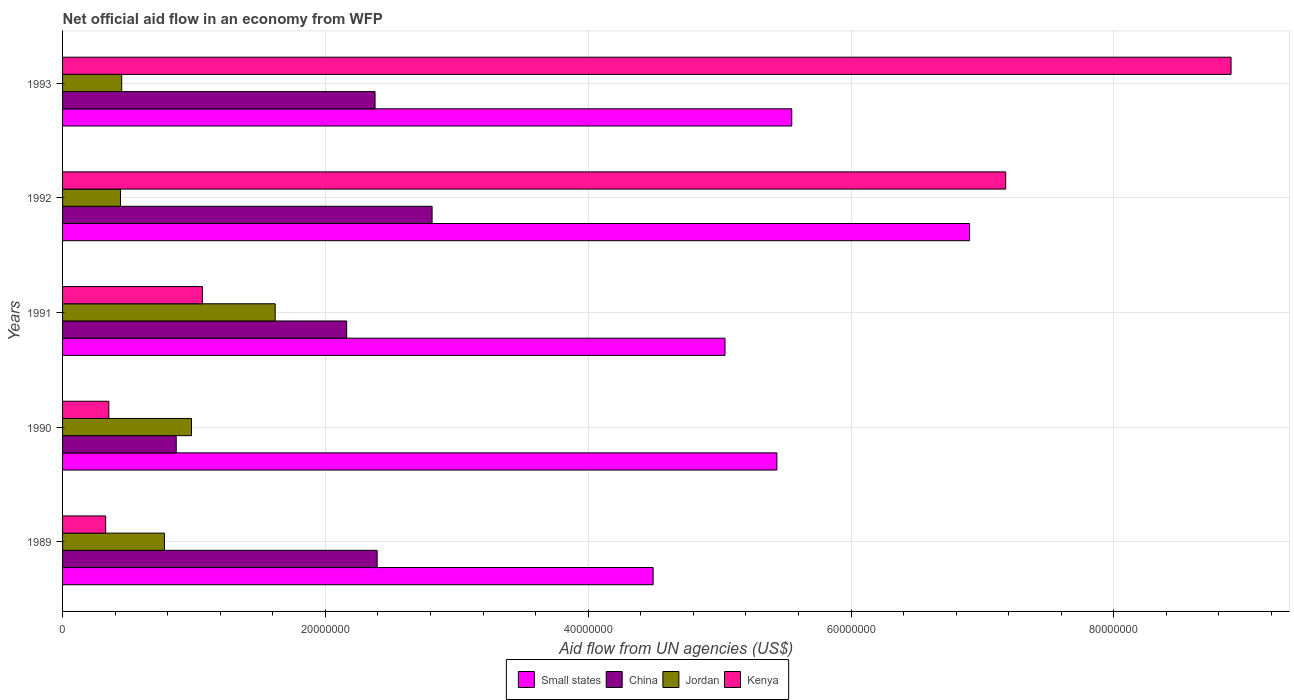How many different coloured bars are there?
Your response must be concise. 4. How many groups of bars are there?
Offer a very short reply. 5. Are the number of bars per tick equal to the number of legend labels?
Your response must be concise. Yes. What is the net official aid flow in Jordan in 1992?
Provide a succinct answer. 4.41e+06. Across all years, what is the maximum net official aid flow in China?
Your answer should be compact. 2.81e+07. Across all years, what is the minimum net official aid flow in China?
Offer a very short reply. 8.65e+06. What is the total net official aid flow in Jordan in the graph?
Your answer should be compact. 4.26e+07. What is the difference between the net official aid flow in Small states in 1991 and that in 1992?
Offer a terse response. -1.86e+07. What is the difference between the net official aid flow in Jordan in 1993 and the net official aid flow in Small states in 1989?
Offer a terse response. -4.04e+07. What is the average net official aid flow in Jordan per year?
Offer a terse response. 8.53e+06. In the year 1991, what is the difference between the net official aid flow in Kenya and net official aid flow in Jordan?
Offer a very short reply. -5.54e+06. In how many years, is the net official aid flow in China greater than 32000000 US$?
Provide a succinct answer. 0. What is the ratio of the net official aid flow in China in 1990 to that in 1993?
Your answer should be very brief. 0.36. Is the difference between the net official aid flow in Kenya in 1990 and 1992 greater than the difference between the net official aid flow in Jordan in 1990 and 1992?
Your answer should be very brief. No. What is the difference between the highest and the second highest net official aid flow in Kenya?
Provide a succinct answer. 1.72e+07. What is the difference between the highest and the lowest net official aid flow in Kenya?
Your response must be concise. 8.56e+07. In how many years, is the net official aid flow in Small states greater than the average net official aid flow in Small states taken over all years?
Give a very brief answer. 2. Is it the case that in every year, the sum of the net official aid flow in Small states and net official aid flow in Kenya is greater than the sum of net official aid flow in China and net official aid flow in Jordan?
Ensure brevity in your answer.  Yes. What does the 2nd bar from the bottom in 1990 represents?
Ensure brevity in your answer.  China. Are all the bars in the graph horizontal?
Make the answer very short. Yes. How many years are there in the graph?
Your answer should be very brief. 5. What is the difference between two consecutive major ticks on the X-axis?
Provide a succinct answer. 2.00e+07. Does the graph contain grids?
Make the answer very short. Yes. How many legend labels are there?
Keep it short and to the point. 4. How are the legend labels stacked?
Provide a succinct answer. Horizontal. What is the title of the graph?
Keep it short and to the point. Net official aid flow in an economy from WFP. What is the label or title of the X-axis?
Your answer should be compact. Aid flow from UN agencies (US$). What is the Aid flow from UN agencies (US$) of Small states in 1989?
Keep it short and to the point. 4.49e+07. What is the Aid flow from UN agencies (US$) in China in 1989?
Keep it short and to the point. 2.39e+07. What is the Aid flow from UN agencies (US$) of Jordan in 1989?
Your answer should be compact. 7.75e+06. What is the Aid flow from UN agencies (US$) of Kenya in 1989?
Your answer should be very brief. 3.28e+06. What is the Aid flow from UN agencies (US$) of Small states in 1990?
Keep it short and to the point. 5.44e+07. What is the Aid flow from UN agencies (US$) of China in 1990?
Make the answer very short. 8.65e+06. What is the Aid flow from UN agencies (US$) in Jordan in 1990?
Offer a very short reply. 9.81e+06. What is the Aid flow from UN agencies (US$) in Kenya in 1990?
Keep it short and to the point. 3.52e+06. What is the Aid flow from UN agencies (US$) in Small states in 1991?
Offer a very short reply. 5.04e+07. What is the Aid flow from UN agencies (US$) of China in 1991?
Make the answer very short. 2.16e+07. What is the Aid flow from UN agencies (US$) of Jordan in 1991?
Ensure brevity in your answer.  1.62e+07. What is the Aid flow from UN agencies (US$) in Kenya in 1991?
Make the answer very short. 1.06e+07. What is the Aid flow from UN agencies (US$) in Small states in 1992?
Your answer should be compact. 6.90e+07. What is the Aid flow from UN agencies (US$) in China in 1992?
Provide a succinct answer. 2.81e+07. What is the Aid flow from UN agencies (US$) in Jordan in 1992?
Ensure brevity in your answer.  4.41e+06. What is the Aid flow from UN agencies (US$) in Kenya in 1992?
Keep it short and to the point. 7.18e+07. What is the Aid flow from UN agencies (US$) of Small states in 1993?
Keep it short and to the point. 5.55e+07. What is the Aid flow from UN agencies (US$) in China in 1993?
Your response must be concise. 2.38e+07. What is the Aid flow from UN agencies (US$) of Jordan in 1993?
Your answer should be very brief. 4.50e+06. What is the Aid flow from UN agencies (US$) in Kenya in 1993?
Ensure brevity in your answer.  8.89e+07. Across all years, what is the maximum Aid flow from UN agencies (US$) of Small states?
Provide a short and direct response. 6.90e+07. Across all years, what is the maximum Aid flow from UN agencies (US$) of China?
Keep it short and to the point. 2.81e+07. Across all years, what is the maximum Aid flow from UN agencies (US$) of Jordan?
Make the answer very short. 1.62e+07. Across all years, what is the maximum Aid flow from UN agencies (US$) in Kenya?
Ensure brevity in your answer.  8.89e+07. Across all years, what is the minimum Aid flow from UN agencies (US$) in Small states?
Offer a terse response. 4.49e+07. Across all years, what is the minimum Aid flow from UN agencies (US$) of China?
Your answer should be very brief. 8.65e+06. Across all years, what is the minimum Aid flow from UN agencies (US$) in Jordan?
Offer a very short reply. 4.41e+06. Across all years, what is the minimum Aid flow from UN agencies (US$) of Kenya?
Offer a very short reply. 3.28e+06. What is the total Aid flow from UN agencies (US$) in Small states in the graph?
Keep it short and to the point. 2.74e+08. What is the total Aid flow from UN agencies (US$) in China in the graph?
Give a very brief answer. 1.06e+08. What is the total Aid flow from UN agencies (US$) in Jordan in the graph?
Ensure brevity in your answer.  4.26e+07. What is the total Aid flow from UN agencies (US$) of Kenya in the graph?
Offer a terse response. 1.78e+08. What is the difference between the Aid flow from UN agencies (US$) in Small states in 1989 and that in 1990?
Give a very brief answer. -9.42e+06. What is the difference between the Aid flow from UN agencies (US$) of China in 1989 and that in 1990?
Provide a short and direct response. 1.53e+07. What is the difference between the Aid flow from UN agencies (US$) in Jordan in 1989 and that in 1990?
Ensure brevity in your answer.  -2.06e+06. What is the difference between the Aid flow from UN agencies (US$) of Kenya in 1989 and that in 1990?
Provide a short and direct response. -2.40e+05. What is the difference between the Aid flow from UN agencies (US$) of Small states in 1989 and that in 1991?
Your answer should be compact. -5.47e+06. What is the difference between the Aid flow from UN agencies (US$) of China in 1989 and that in 1991?
Keep it short and to the point. 2.32e+06. What is the difference between the Aid flow from UN agencies (US$) in Jordan in 1989 and that in 1991?
Provide a succinct answer. -8.43e+06. What is the difference between the Aid flow from UN agencies (US$) of Kenya in 1989 and that in 1991?
Your answer should be very brief. -7.36e+06. What is the difference between the Aid flow from UN agencies (US$) of Small states in 1989 and that in 1992?
Offer a terse response. -2.41e+07. What is the difference between the Aid flow from UN agencies (US$) in China in 1989 and that in 1992?
Make the answer very short. -4.18e+06. What is the difference between the Aid flow from UN agencies (US$) in Jordan in 1989 and that in 1992?
Your response must be concise. 3.34e+06. What is the difference between the Aid flow from UN agencies (US$) in Kenya in 1989 and that in 1992?
Your answer should be very brief. -6.85e+07. What is the difference between the Aid flow from UN agencies (US$) in Small states in 1989 and that in 1993?
Keep it short and to the point. -1.06e+07. What is the difference between the Aid flow from UN agencies (US$) in Jordan in 1989 and that in 1993?
Keep it short and to the point. 3.25e+06. What is the difference between the Aid flow from UN agencies (US$) in Kenya in 1989 and that in 1993?
Give a very brief answer. -8.56e+07. What is the difference between the Aid flow from UN agencies (US$) of Small states in 1990 and that in 1991?
Your response must be concise. 3.95e+06. What is the difference between the Aid flow from UN agencies (US$) of China in 1990 and that in 1991?
Provide a succinct answer. -1.30e+07. What is the difference between the Aid flow from UN agencies (US$) in Jordan in 1990 and that in 1991?
Your answer should be very brief. -6.37e+06. What is the difference between the Aid flow from UN agencies (US$) in Kenya in 1990 and that in 1991?
Ensure brevity in your answer.  -7.12e+06. What is the difference between the Aid flow from UN agencies (US$) in Small states in 1990 and that in 1992?
Provide a short and direct response. -1.47e+07. What is the difference between the Aid flow from UN agencies (US$) in China in 1990 and that in 1992?
Offer a terse response. -1.95e+07. What is the difference between the Aid flow from UN agencies (US$) of Jordan in 1990 and that in 1992?
Keep it short and to the point. 5.40e+06. What is the difference between the Aid flow from UN agencies (US$) of Kenya in 1990 and that in 1992?
Provide a short and direct response. -6.82e+07. What is the difference between the Aid flow from UN agencies (US$) in Small states in 1990 and that in 1993?
Provide a short and direct response. -1.13e+06. What is the difference between the Aid flow from UN agencies (US$) in China in 1990 and that in 1993?
Give a very brief answer. -1.51e+07. What is the difference between the Aid flow from UN agencies (US$) of Jordan in 1990 and that in 1993?
Offer a very short reply. 5.31e+06. What is the difference between the Aid flow from UN agencies (US$) in Kenya in 1990 and that in 1993?
Provide a short and direct response. -8.54e+07. What is the difference between the Aid flow from UN agencies (US$) of Small states in 1991 and that in 1992?
Make the answer very short. -1.86e+07. What is the difference between the Aid flow from UN agencies (US$) of China in 1991 and that in 1992?
Provide a succinct answer. -6.50e+06. What is the difference between the Aid flow from UN agencies (US$) in Jordan in 1991 and that in 1992?
Offer a terse response. 1.18e+07. What is the difference between the Aid flow from UN agencies (US$) of Kenya in 1991 and that in 1992?
Your response must be concise. -6.11e+07. What is the difference between the Aid flow from UN agencies (US$) in Small states in 1991 and that in 1993?
Offer a very short reply. -5.08e+06. What is the difference between the Aid flow from UN agencies (US$) in China in 1991 and that in 1993?
Your answer should be compact. -2.16e+06. What is the difference between the Aid flow from UN agencies (US$) in Jordan in 1991 and that in 1993?
Your answer should be very brief. 1.17e+07. What is the difference between the Aid flow from UN agencies (US$) of Kenya in 1991 and that in 1993?
Provide a short and direct response. -7.83e+07. What is the difference between the Aid flow from UN agencies (US$) in Small states in 1992 and that in 1993?
Your answer should be very brief. 1.35e+07. What is the difference between the Aid flow from UN agencies (US$) in China in 1992 and that in 1993?
Provide a short and direct response. 4.34e+06. What is the difference between the Aid flow from UN agencies (US$) in Kenya in 1992 and that in 1993?
Provide a short and direct response. -1.72e+07. What is the difference between the Aid flow from UN agencies (US$) of Small states in 1989 and the Aid flow from UN agencies (US$) of China in 1990?
Your answer should be very brief. 3.63e+07. What is the difference between the Aid flow from UN agencies (US$) in Small states in 1989 and the Aid flow from UN agencies (US$) in Jordan in 1990?
Provide a succinct answer. 3.51e+07. What is the difference between the Aid flow from UN agencies (US$) of Small states in 1989 and the Aid flow from UN agencies (US$) of Kenya in 1990?
Make the answer very short. 4.14e+07. What is the difference between the Aid flow from UN agencies (US$) in China in 1989 and the Aid flow from UN agencies (US$) in Jordan in 1990?
Provide a succinct answer. 1.41e+07. What is the difference between the Aid flow from UN agencies (US$) in China in 1989 and the Aid flow from UN agencies (US$) in Kenya in 1990?
Offer a very short reply. 2.04e+07. What is the difference between the Aid flow from UN agencies (US$) in Jordan in 1989 and the Aid flow from UN agencies (US$) in Kenya in 1990?
Make the answer very short. 4.23e+06. What is the difference between the Aid flow from UN agencies (US$) in Small states in 1989 and the Aid flow from UN agencies (US$) in China in 1991?
Offer a very short reply. 2.33e+07. What is the difference between the Aid flow from UN agencies (US$) in Small states in 1989 and the Aid flow from UN agencies (US$) in Jordan in 1991?
Keep it short and to the point. 2.88e+07. What is the difference between the Aid flow from UN agencies (US$) of Small states in 1989 and the Aid flow from UN agencies (US$) of Kenya in 1991?
Provide a short and direct response. 3.43e+07. What is the difference between the Aid flow from UN agencies (US$) in China in 1989 and the Aid flow from UN agencies (US$) in Jordan in 1991?
Offer a very short reply. 7.76e+06. What is the difference between the Aid flow from UN agencies (US$) in China in 1989 and the Aid flow from UN agencies (US$) in Kenya in 1991?
Your answer should be very brief. 1.33e+07. What is the difference between the Aid flow from UN agencies (US$) of Jordan in 1989 and the Aid flow from UN agencies (US$) of Kenya in 1991?
Give a very brief answer. -2.89e+06. What is the difference between the Aid flow from UN agencies (US$) of Small states in 1989 and the Aid flow from UN agencies (US$) of China in 1992?
Your answer should be very brief. 1.68e+07. What is the difference between the Aid flow from UN agencies (US$) of Small states in 1989 and the Aid flow from UN agencies (US$) of Jordan in 1992?
Your answer should be compact. 4.05e+07. What is the difference between the Aid flow from UN agencies (US$) of Small states in 1989 and the Aid flow from UN agencies (US$) of Kenya in 1992?
Offer a very short reply. -2.68e+07. What is the difference between the Aid flow from UN agencies (US$) in China in 1989 and the Aid flow from UN agencies (US$) in Jordan in 1992?
Your response must be concise. 1.95e+07. What is the difference between the Aid flow from UN agencies (US$) of China in 1989 and the Aid flow from UN agencies (US$) of Kenya in 1992?
Keep it short and to the point. -4.78e+07. What is the difference between the Aid flow from UN agencies (US$) in Jordan in 1989 and the Aid flow from UN agencies (US$) in Kenya in 1992?
Offer a terse response. -6.40e+07. What is the difference between the Aid flow from UN agencies (US$) of Small states in 1989 and the Aid flow from UN agencies (US$) of China in 1993?
Your answer should be very brief. 2.12e+07. What is the difference between the Aid flow from UN agencies (US$) in Small states in 1989 and the Aid flow from UN agencies (US$) in Jordan in 1993?
Give a very brief answer. 4.04e+07. What is the difference between the Aid flow from UN agencies (US$) in Small states in 1989 and the Aid flow from UN agencies (US$) in Kenya in 1993?
Offer a terse response. -4.40e+07. What is the difference between the Aid flow from UN agencies (US$) in China in 1989 and the Aid flow from UN agencies (US$) in Jordan in 1993?
Your answer should be very brief. 1.94e+07. What is the difference between the Aid flow from UN agencies (US$) of China in 1989 and the Aid flow from UN agencies (US$) of Kenya in 1993?
Your answer should be very brief. -6.50e+07. What is the difference between the Aid flow from UN agencies (US$) in Jordan in 1989 and the Aid flow from UN agencies (US$) in Kenya in 1993?
Your answer should be very brief. -8.12e+07. What is the difference between the Aid flow from UN agencies (US$) in Small states in 1990 and the Aid flow from UN agencies (US$) in China in 1991?
Your answer should be very brief. 3.27e+07. What is the difference between the Aid flow from UN agencies (US$) of Small states in 1990 and the Aid flow from UN agencies (US$) of Jordan in 1991?
Your answer should be compact. 3.82e+07. What is the difference between the Aid flow from UN agencies (US$) in Small states in 1990 and the Aid flow from UN agencies (US$) in Kenya in 1991?
Your answer should be very brief. 4.37e+07. What is the difference between the Aid flow from UN agencies (US$) in China in 1990 and the Aid flow from UN agencies (US$) in Jordan in 1991?
Provide a succinct answer. -7.53e+06. What is the difference between the Aid flow from UN agencies (US$) in China in 1990 and the Aid flow from UN agencies (US$) in Kenya in 1991?
Offer a terse response. -1.99e+06. What is the difference between the Aid flow from UN agencies (US$) of Jordan in 1990 and the Aid flow from UN agencies (US$) of Kenya in 1991?
Keep it short and to the point. -8.30e+05. What is the difference between the Aid flow from UN agencies (US$) of Small states in 1990 and the Aid flow from UN agencies (US$) of China in 1992?
Offer a very short reply. 2.62e+07. What is the difference between the Aid flow from UN agencies (US$) of Small states in 1990 and the Aid flow from UN agencies (US$) of Jordan in 1992?
Make the answer very short. 5.00e+07. What is the difference between the Aid flow from UN agencies (US$) of Small states in 1990 and the Aid flow from UN agencies (US$) of Kenya in 1992?
Make the answer very short. -1.74e+07. What is the difference between the Aid flow from UN agencies (US$) in China in 1990 and the Aid flow from UN agencies (US$) in Jordan in 1992?
Offer a terse response. 4.24e+06. What is the difference between the Aid flow from UN agencies (US$) in China in 1990 and the Aid flow from UN agencies (US$) in Kenya in 1992?
Your answer should be compact. -6.31e+07. What is the difference between the Aid flow from UN agencies (US$) of Jordan in 1990 and the Aid flow from UN agencies (US$) of Kenya in 1992?
Your response must be concise. -6.20e+07. What is the difference between the Aid flow from UN agencies (US$) in Small states in 1990 and the Aid flow from UN agencies (US$) in China in 1993?
Give a very brief answer. 3.06e+07. What is the difference between the Aid flow from UN agencies (US$) in Small states in 1990 and the Aid flow from UN agencies (US$) in Jordan in 1993?
Your answer should be very brief. 4.99e+07. What is the difference between the Aid flow from UN agencies (US$) in Small states in 1990 and the Aid flow from UN agencies (US$) in Kenya in 1993?
Your answer should be very brief. -3.46e+07. What is the difference between the Aid flow from UN agencies (US$) in China in 1990 and the Aid flow from UN agencies (US$) in Jordan in 1993?
Give a very brief answer. 4.15e+06. What is the difference between the Aid flow from UN agencies (US$) of China in 1990 and the Aid flow from UN agencies (US$) of Kenya in 1993?
Ensure brevity in your answer.  -8.03e+07. What is the difference between the Aid flow from UN agencies (US$) of Jordan in 1990 and the Aid flow from UN agencies (US$) of Kenya in 1993?
Provide a succinct answer. -7.91e+07. What is the difference between the Aid flow from UN agencies (US$) of Small states in 1991 and the Aid flow from UN agencies (US$) of China in 1992?
Offer a terse response. 2.23e+07. What is the difference between the Aid flow from UN agencies (US$) in Small states in 1991 and the Aid flow from UN agencies (US$) in Jordan in 1992?
Give a very brief answer. 4.60e+07. What is the difference between the Aid flow from UN agencies (US$) of Small states in 1991 and the Aid flow from UN agencies (US$) of Kenya in 1992?
Ensure brevity in your answer.  -2.14e+07. What is the difference between the Aid flow from UN agencies (US$) in China in 1991 and the Aid flow from UN agencies (US$) in Jordan in 1992?
Ensure brevity in your answer.  1.72e+07. What is the difference between the Aid flow from UN agencies (US$) in China in 1991 and the Aid flow from UN agencies (US$) in Kenya in 1992?
Give a very brief answer. -5.02e+07. What is the difference between the Aid flow from UN agencies (US$) in Jordan in 1991 and the Aid flow from UN agencies (US$) in Kenya in 1992?
Keep it short and to the point. -5.56e+07. What is the difference between the Aid flow from UN agencies (US$) of Small states in 1991 and the Aid flow from UN agencies (US$) of China in 1993?
Your answer should be compact. 2.66e+07. What is the difference between the Aid flow from UN agencies (US$) of Small states in 1991 and the Aid flow from UN agencies (US$) of Jordan in 1993?
Ensure brevity in your answer.  4.59e+07. What is the difference between the Aid flow from UN agencies (US$) of Small states in 1991 and the Aid flow from UN agencies (US$) of Kenya in 1993?
Provide a succinct answer. -3.85e+07. What is the difference between the Aid flow from UN agencies (US$) in China in 1991 and the Aid flow from UN agencies (US$) in Jordan in 1993?
Your answer should be compact. 1.71e+07. What is the difference between the Aid flow from UN agencies (US$) of China in 1991 and the Aid flow from UN agencies (US$) of Kenya in 1993?
Provide a succinct answer. -6.73e+07. What is the difference between the Aid flow from UN agencies (US$) of Jordan in 1991 and the Aid flow from UN agencies (US$) of Kenya in 1993?
Offer a terse response. -7.27e+07. What is the difference between the Aid flow from UN agencies (US$) of Small states in 1992 and the Aid flow from UN agencies (US$) of China in 1993?
Offer a very short reply. 4.52e+07. What is the difference between the Aid flow from UN agencies (US$) of Small states in 1992 and the Aid flow from UN agencies (US$) of Jordan in 1993?
Your answer should be compact. 6.45e+07. What is the difference between the Aid flow from UN agencies (US$) in Small states in 1992 and the Aid flow from UN agencies (US$) in Kenya in 1993?
Your response must be concise. -1.99e+07. What is the difference between the Aid flow from UN agencies (US$) in China in 1992 and the Aid flow from UN agencies (US$) in Jordan in 1993?
Provide a succinct answer. 2.36e+07. What is the difference between the Aid flow from UN agencies (US$) in China in 1992 and the Aid flow from UN agencies (US$) in Kenya in 1993?
Offer a terse response. -6.08e+07. What is the difference between the Aid flow from UN agencies (US$) of Jordan in 1992 and the Aid flow from UN agencies (US$) of Kenya in 1993?
Offer a terse response. -8.45e+07. What is the average Aid flow from UN agencies (US$) of Small states per year?
Your answer should be very brief. 5.48e+07. What is the average Aid flow from UN agencies (US$) of China per year?
Offer a very short reply. 2.12e+07. What is the average Aid flow from UN agencies (US$) of Jordan per year?
Offer a terse response. 8.53e+06. What is the average Aid flow from UN agencies (US$) of Kenya per year?
Provide a succinct answer. 3.56e+07. In the year 1989, what is the difference between the Aid flow from UN agencies (US$) in Small states and Aid flow from UN agencies (US$) in China?
Ensure brevity in your answer.  2.10e+07. In the year 1989, what is the difference between the Aid flow from UN agencies (US$) in Small states and Aid flow from UN agencies (US$) in Jordan?
Offer a terse response. 3.72e+07. In the year 1989, what is the difference between the Aid flow from UN agencies (US$) in Small states and Aid flow from UN agencies (US$) in Kenya?
Make the answer very short. 4.17e+07. In the year 1989, what is the difference between the Aid flow from UN agencies (US$) of China and Aid flow from UN agencies (US$) of Jordan?
Give a very brief answer. 1.62e+07. In the year 1989, what is the difference between the Aid flow from UN agencies (US$) of China and Aid flow from UN agencies (US$) of Kenya?
Ensure brevity in your answer.  2.07e+07. In the year 1989, what is the difference between the Aid flow from UN agencies (US$) in Jordan and Aid flow from UN agencies (US$) in Kenya?
Ensure brevity in your answer.  4.47e+06. In the year 1990, what is the difference between the Aid flow from UN agencies (US$) in Small states and Aid flow from UN agencies (US$) in China?
Offer a very short reply. 4.57e+07. In the year 1990, what is the difference between the Aid flow from UN agencies (US$) of Small states and Aid flow from UN agencies (US$) of Jordan?
Offer a very short reply. 4.46e+07. In the year 1990, what is the difference between the Aid flow from UN agencies (US$) in Small states and Aid flow from UN agencies (US$) in Kenya?
Your response must be concise. 5.08e+07. In the year 1990, what is the difference between the Aid flow from UN agencies (US$) in China and Aid flow from UN agencies (US$) in Jordan?
Make the answer very short. -1.16e+06. In the year 1990, what is the difference between the Aid flow from UN agencies (US$) in China and Aid flow from UN agencies (US$) in Kenya?
Your answer should be compact. 5.13e+06. In the year 1990, what is the difference between the Aid flow from UN agencies (US$) in Jordan and Aid flow from UN agencies (US$) in Kenya?
Your response must be concise. 6.29e+06. In the year 1991, what is the difference between the Aid flow from UN agencies (US$) of Small states and Aid flow from UN agencies (US$) of China?
Give a very brief answer. 2.88e+07. In the year 1991, what is the difference between the Aid flow from UN agencies (US$) of Small states and Aid flow from UN agencies (US$) of Jordan?
Provide a succinct answer. 3.42e+07. In the year 1991, what is the difference between the Aid flow from UN agencies (US$) in Small states and Aid flow from UN agencies (US$) in Kenya?
Give a very brief answer. 3.98e+07. In the year 1991, what is the difference between the Aid flow from UN agencies (US$) of China and Aid flow from UN agencies (US$) of Jordan?
Keep it short and to the point. 5.44e+06. In the year 1991, what is the difference between the Aid flow from UN agencies (US$) in China and Aid flow from UN agencies (US$) in Kenya?
Keep it short and to the point. 1.10e+07. In the year 1991, what is the difference between the Aid flow from UN agencies (US$) in Jordan and Aid flow from UN agencies (US$) in Kenya?
Your answer should be compact. 5.54e+06. In the year 1992, what is the difference between the Aid flow from UN agencies (US$) of Small states and Aid flow from UN agencies (US$) of China?
Provide a succinct answer. 4.09e+07. In the year 1992, what is the difference between the Aid flow from UN agencies (US$) of Small states and Aid flow from UN agencies (US$) of Jordan?
Keep it short and to the point. 6.46e+07. In the year 1992, what is the difference between the Aid flow from UN agencies (US$) of Small states and Aid flow from UN agencies (US$) of Kenya?
Ensure brevity in your answer.  -2.75e+06. In the year 1992, what is the difference between the Aid flow from UN agencies (US$) of China and Aid flow from UN agencies (US$) of Jordan?
Ensure brevity in your answer.  2.37e+07. In the year 1992, what is the difference between the Aid flow from UN agencies (US$) of China and Aid flow from UN agencies (US$) of Kenya?
Provide a short and direct response. -4.36e+07. In the year 1992, what is the difference between the Aid flow from UN agencies (US$) of Jordan and Aid flow from UN agencies (US$) of Kenya?
Your answer should be very brief. -6.74e+07. In the year 1993, what is the difference between the Aid flow from UN agencies (US$) in Small states and Aid flow from UN agencies (US$) in China?
Provide a succinct answer. 3.17e+07. In the year 1993, what is the difference between the Aid flow from UN agencies (US$) in Small states and Aid flow from UN agencies (US$) in Jordan?
Provide a succinct answer. 5.10e+07. In the year 1993, what is the difference between the Aid flow from UN agencies (US$) of Small states and Aid flow from UN agencies (US$) of Kenya?
Your answer should be very brief. -3.34e+07. In the year 1993, what is the difference between the Aid flow from UN agencies (US$) of China and Aid flow from UN agencies (US$) of Jordan?
Make the answer very short. 1.93e+07. In the year 1993, what is the difference between the Aid flow from UN agencies (US$) in China and Aid flow from UN agencies (US$) in Kenya?
Keep it short and to the point. -6.51e+07. In the year 1993, what is the difference between the Aid flow from UN agencies (US$) of Jordan and Aid flow from UN agencies (US$) of Kenya?
Keep it short and to the point. -8.44e+07. What is the ratio of the Aid flow from UN agencies (US$) of Small states in 1989 to that in 1990?
Offer a terse response. 0.83. What is the ratio of the Aid flow from UN agencies (US$) of China in 1989 to that in 1990?
Keep it short and to the point. 2.77. What is the ratio of the Aid flow from UN agencies (US$) of Jordan in 1989 to that in 1990?
Your answer should be compact. 0.79. What is the ratio of the Aid flow from UN agencies (US$) in Kenya in 1989 to that in 1990?
Give a very brief answer. 0.93. What is the ratio of the Aid flow from UN agencies (US$) in Small states in 1989 to that in 1991?
Make the answer very short. 0.89. What is the ratio of the Aid flow from UN agencies (US$) of China in 1989 to that in 1991?
Provide a succinct answer. 1.11. What is the ratio of the Aid flow from UN agencies (US$) of Jordan in 1989 to that in 1991?
Offer a very short reply. 0.48. What is the ratio of the Aid flow from UN agencies (US$) in Kenya in 1989 to that in 1991?
Offer a terse response. 0.31. What is the ratio of the Aid flow from UN agencies (US$) in Small states in 1989 to that in 1992?
Give a very brief answer. 0.65. What is the ratio of the Aid flow from UN agencies (US$) in China in 1989 to that in 1992?
Keep it short and to the point. 0.85. What is the ratio of the Aid flow from UN agencies (US$) of Jordan in 1989 to that in 1992?
Keep it short and to the point. 1.76. What is the ratio of the Aid flow from UN agencies (US$) in Kenya in 1989 to that in 1992?
Your response must be concise. 0.05. What is the ratio of the Aid flow from UN agencies (US$) of Small states in 1989 to that in 1993?
Offer a terse response. 0.81. What is the ratio of the Aid flow from UN agencies (US$) in Jordan in 1989 to that in 1993?
Offer a terse response. 1.72. What is the ratio of the Aid flow from UN agencies (US$) in Kenya in 1989 to that in 1993?
Offer a very short reply. 0.04. What is the ratio of the Aid flow from UN agencies (US$) in Small states in 1990 to that in 1991?
Ensure brevity in your answer.  1.08. What is the ratio of the Aid flow from UN agencies (US$) of China in 1990 to that in 1991?
Offer a terse response. 0.4. What is the ratio of the Aid flow from UN agencies (US$) of Jordan in 1990 to that in 1991?
Offer a terse response. 0.61. What is the ratio of the Aid flow from UN agencies (US$) of Kenya in 1990 to that in 1991?
Give a very brief answer. 0.33. What is the ratio of the Aid flow from UN agencies (US$) of Small states in 1990 to that in 1992?
Keep it short and to the point. 0.79. What is the ratio of the Aid flow from UN agencies (US$) of China in 1990 to that in 1992?
Ensure brevity in your answer.  0.31. What is the ratio of the Aid flow from UN agencies (US$) in Jordan in 1990 to that in 1992?
Offer a very short reply. 2.22. What is the ratio of the Aid flow from UN agencies (US$) of Kenya in 1990 to that in 1992?
Ensure brevity in your answer.  0.05. What is the ratio of the Aid flow from UN agencies (US$) of Small states in 1990 to that in 1993?
Your response must be concise. 0.98. What is the ratio of the Aid flow from UN agencies (US$) in China in 1990 to that in 1993?
Your answer should be compact. 0.36. What is the ratio of the Aid flow from UN agencies (US$) in Jordan in 1990 to that in 1993?
Your answer should be very brief. 2.18. What is the ratio of the Aid flow from UN agencies (US$) in Kenya in 1990 to that in 1993?
Make the answer very short. 0.04. What is the ratio of the Aid flow from UN agencies (US$) of Small states in 1991 to that in 1992?
Make the answer very short. 0.73. What is the ratio of the Aid flow from UN agencies (US$) of China in 1991 to that in 1992?
Give a very brief answer. 0.77. What is the ratio of the Aid flow from UN agencies (US$) of Jordan in 1991 to that in 1992?
Provide a succinct answer. 3.67. What is the ratio of the Aid flow from UN agencies (US$) in Kenya in 1991 to that in 1992?
Make the answer very short. 0.15. What is the ratio of the Aid flow from UN agencies (US$) of Small states in 1991 to that in 1993?
Make the answer very short. 0.91. What is the ratio of the Aid flow from UN agencies (US$) in China in 1991 to that in 1993?
Your answer should be compact. 0.91. What is the ratio of the Aid flow from UN agencies (US$) in Jordan in 1991 to that in 1993?
Your response must be concise. 3.6. What is the ratio of the Aid flow from UN agencies (US$) in Kenya in 1991 to that in 1993?
Ensure brevity in your answer.  0.12. What is the ratio of the Aid flow from UN agencies (US$) in Small states in 1992 to that in 1993?
Provide a short and direct response. 1.24. What is the ratio of the Aid flow from UN agencies (US$) of China in 1992 to that in 1993?
Keep it short and to the point. 1.18. What is the ratio of the Aid flow from UN agencies (US$) of Jordan in 1992 to that in 1993?
Your answer should be compact. 0.98. What is the ratio of the Aid flow from UN agencies (US$) of Kenya in 1992 to that in 1993?
Offer a terse response. 0.81. What is the difference between the highest and the second highest Aid flow from UN agencies (US$) of Small states?
Provide a succinct answer. 1.35e+07. What is the difference between the highest and the second highest Aid flow from UN agencies (US$) in China?
Offer a terse response. 4.18e+06. What is the difference between the highest and the second highest Aid flow from UN agencies (US$) in Jordan?
Ensure brevity in your answer.  6.37e+06. What is the difference between the highest and the second highest Aid flow from UN agencies (US$) in Kenya?
Provide a short and direct response. 1.72e+07. What is the difference between the highest and the lowest Aid flow from UN agencies (US$) of Small states?
Provide a succinct answer. 2.41e+07. What is the difference between the highest and the lowest Aid flow from UN agencies (US$) of China?
Ensure brevity in your answer.  1.95e+07. What is the difference between the highest and the lowest Aid flow from UN agencies (US$) in Jordan?
Give a very brief answer. 1.18e+07. What is the difference between the highest and the lowest Aid flow from UN agencies (US$) in Kenya?
Provide a succinct answer. 8.56e+07. 